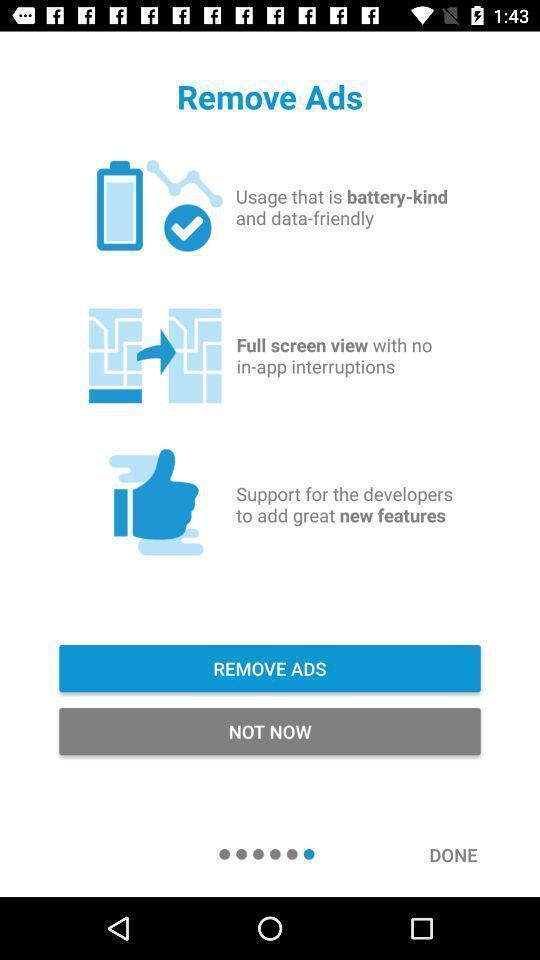Provide a textual representation of this image. Screen shows removed ads options. 